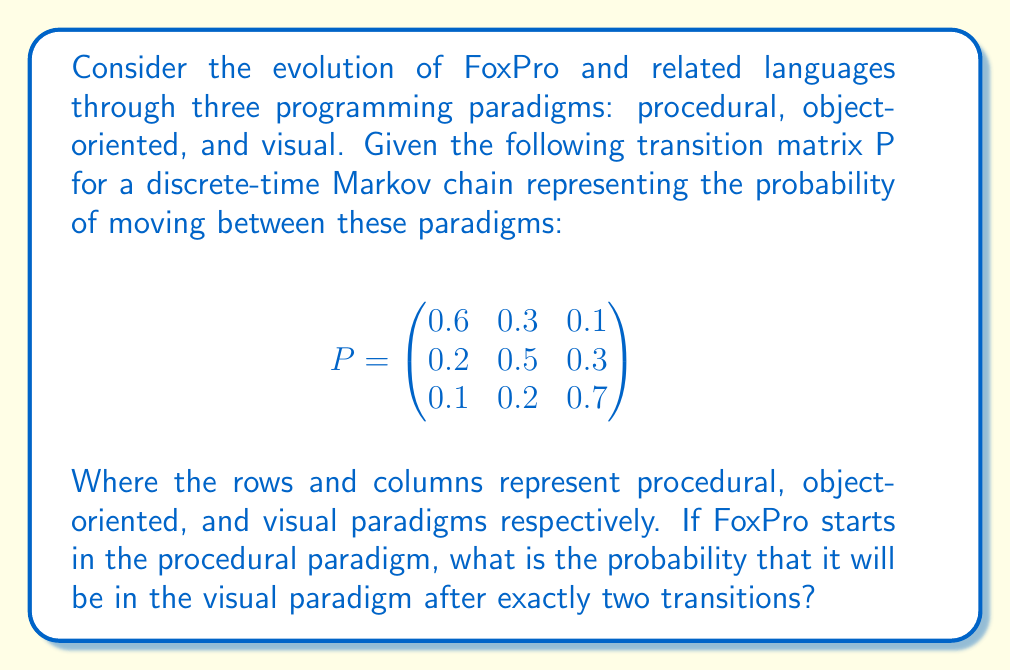Provide a solution to this math problem. To solve this problem, we need to use the Chapman-Kolmogorov equations for a two-step transition. The probability of going from state i to state j in exactly two steps is given by:

$$ p_{ij}^{(2)} = \sum_{k=1}^{3} p_{ik}^{(1)} p_{kj}^{(1)} $$

Where $p_{ij}^{(2)}$ is the two-step transition probability from state i to state j, and $p_{ik}^{(1)}$ and $p_{kj}^{(1)}$ are one-step transition probabilities.

We want to find $p_{13}^{(2)}$, which is the probability of going from the procedural paradigm (state 1) to the visual paradigm (state 3) in two steps.

Let's calculate:

$p_{13}^{(2)} = p_{11}^{(1)} p_{13}^{(1)} + p_{12}^{(1)} p_{23}^{(1)} + p_{13}^{(1)} p_{33}^{(1)}$

Substituting the values from the given transition matrix:

$p_{13}^{(2)} = (0.6 \times 0.1) + (0.3 \times 0.3) + (0.1 \times 0.7)$

$p_{13}^{(2)} = 0.06 + 0.09 + 0.07$

$p_{13}^{(2)} = 0.22$

Therefore, the probability that FoxPro will be in the visual paradigm after exactly two transitions, starting from the procedural paradigm, is 0.22 or 22%.
Answer: 0.22 